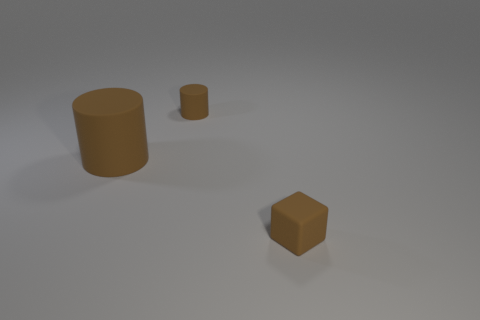How many brown cylinders must be subtracted to get 1 brown cylinders? 1 Add 1 large yellow matte balls. How many objects exist? 4 Subtract 0 gray spheres. How many objects are left? 3 Subtract all blocks. How many objects are left? 2 Subtract 1 cylinders. How many cylinders are left? 1 Subtract all cyan cylinders. Subtract all yellow cubes. How many cylinders are left? 2 Subtract all purple balls. How many purple cylinders are left? 0 Subtract all large rubber cylinders. Subtract all large red rubber cylinders. How many objects are left? 2 Add 1 big brown matte objects. How many big brown matte objects are left? 2 Add 3 tiny blocks. How many tiny blocks exist? 4 